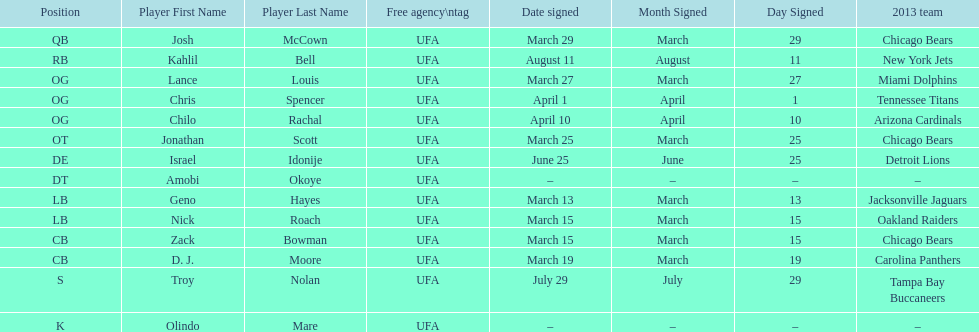Last name is also a first name beginning with "n" Troy Nolan. 